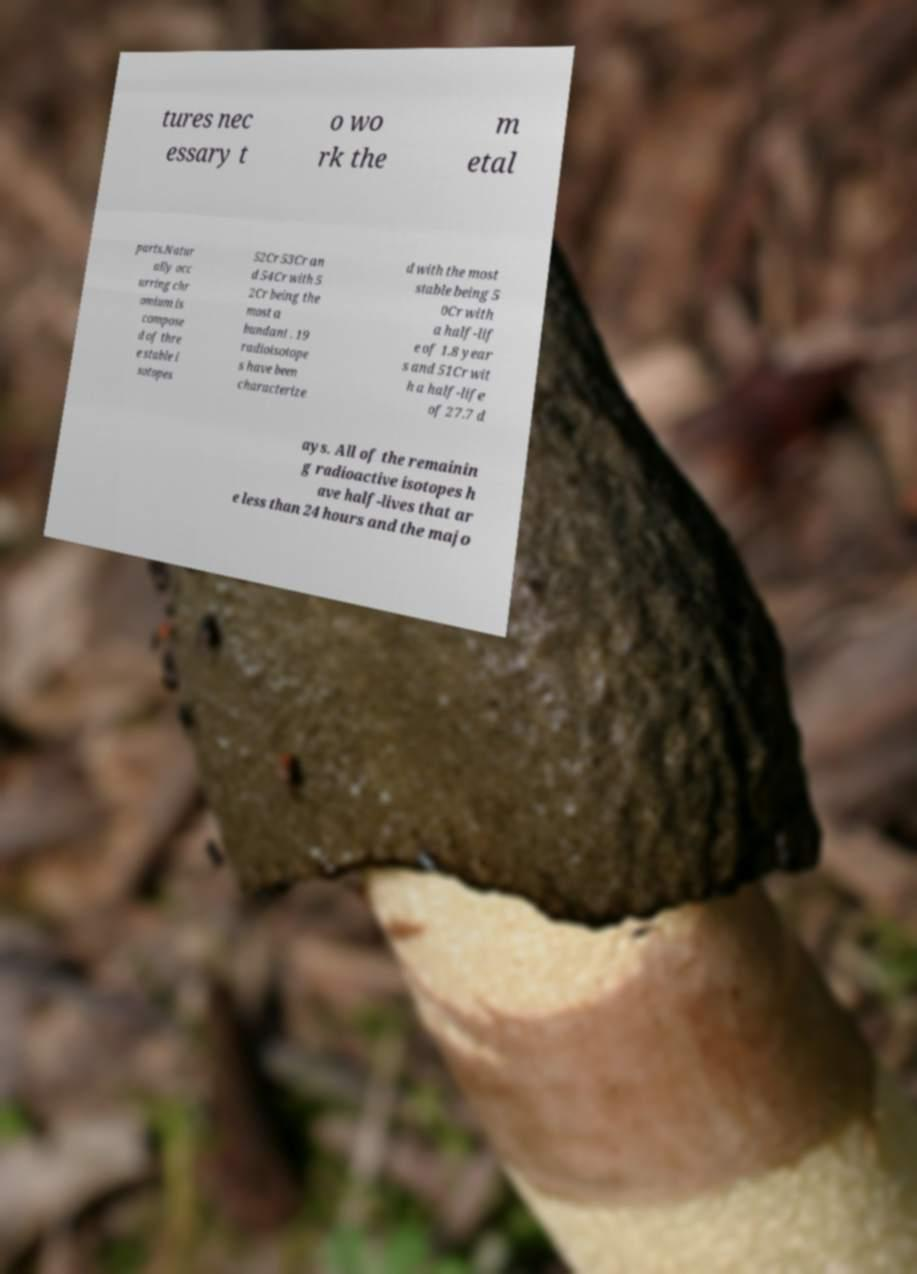Could you extract and type out the text from this image? tures nec essary t o wo rk the m etal parts.Natur ally occ urring chr omium is compose d of thre e stable i sotopes 52Cr 53Cr an d 54Cr with 5 2Cr being the most a bundant . 19 radioisotope s have been characterize d with the most stable being 5 0Cr with a half-lif e of 1.8 year s and 51Cr wit h a half-life of 27.7 d ays. All of the remainin g radioactive isotopes h ave half-lives that ar e less than 24 hours and the majo 